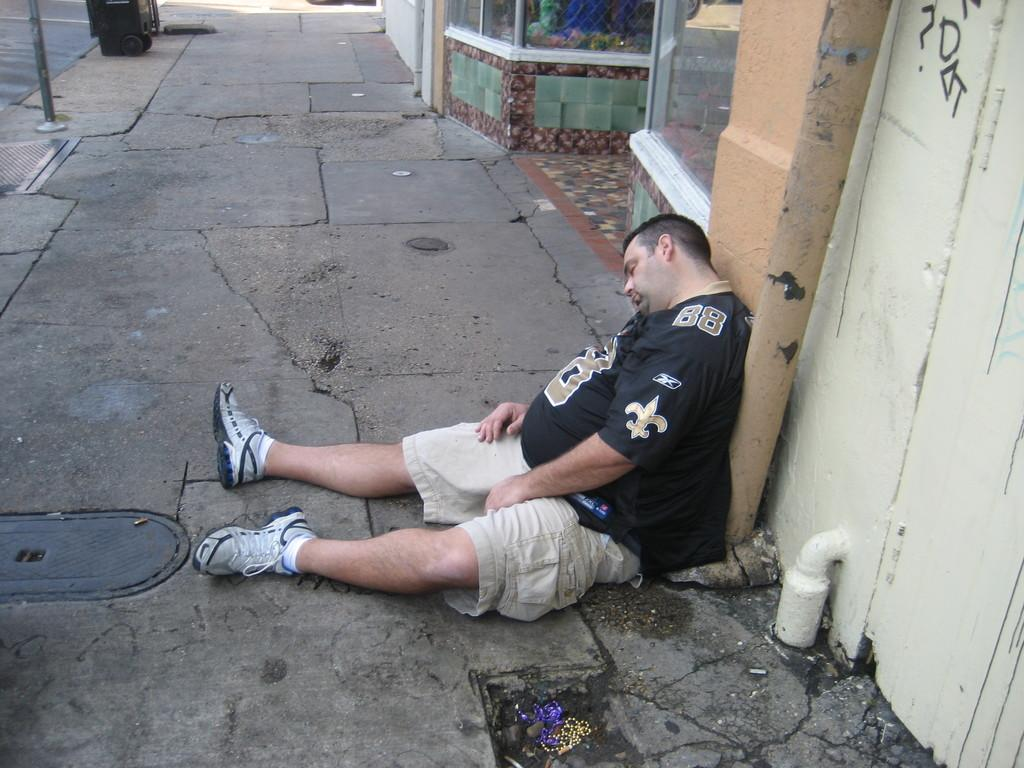What is the person in the image doing? There is a person sleeping on the road in the image. What is located behind the person? There is a pillar behind the person. What type of structure can be seen in the image? There is a wall in the image. What is on the left side of the image? There is a pole on the left side of the image. What stands out in terms of color in the image? There is a colorful object in the image. What type of harmony is being played during the dinner in the image? There is no dinner or harmony present in the image; it features a person sleeping on the road with various structures and a colorful object nearby. 